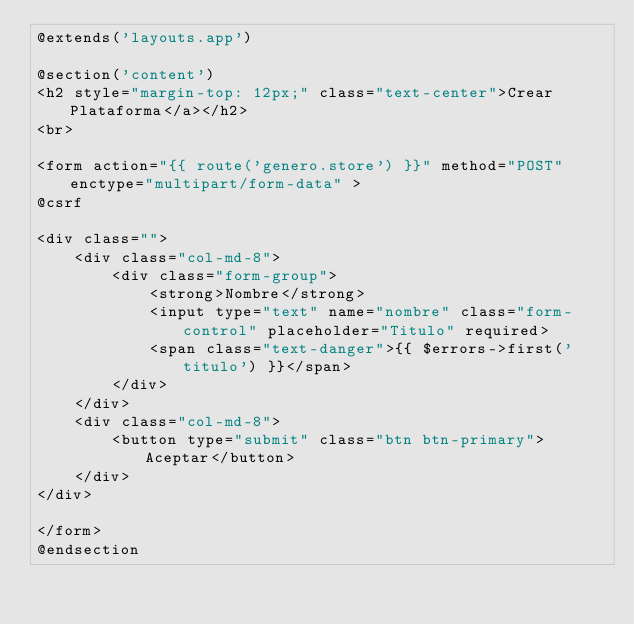<code> <loc_0><loc_0><loc_500><loc_500><_PHP_>@extends('layouts.app')

@section('content')
<h2 style="margin-top: 12px;" class="text-center">Crear Plataforma</a></h2>
<br>

<form action="{{ route('genero.store') }}" method="POST" enctype="multipart/form-data" >
@csrf

<div class="">
    <div class="col-md-8">
        <div class="form-group">
            <strong>Nombre</strong>
            <input type="text" name="nombre" class="form-control" placeholder="Titulo" required>
            <span class="text-danger">{{ $errors->first('titulo') }}</span>
        </div>
    </div>
    <div class="col-md-8">
        <button type="submit" class="btn btn-primary">Aceptar</button>
    </div>
</div>

</form>
@endsection
</code> 